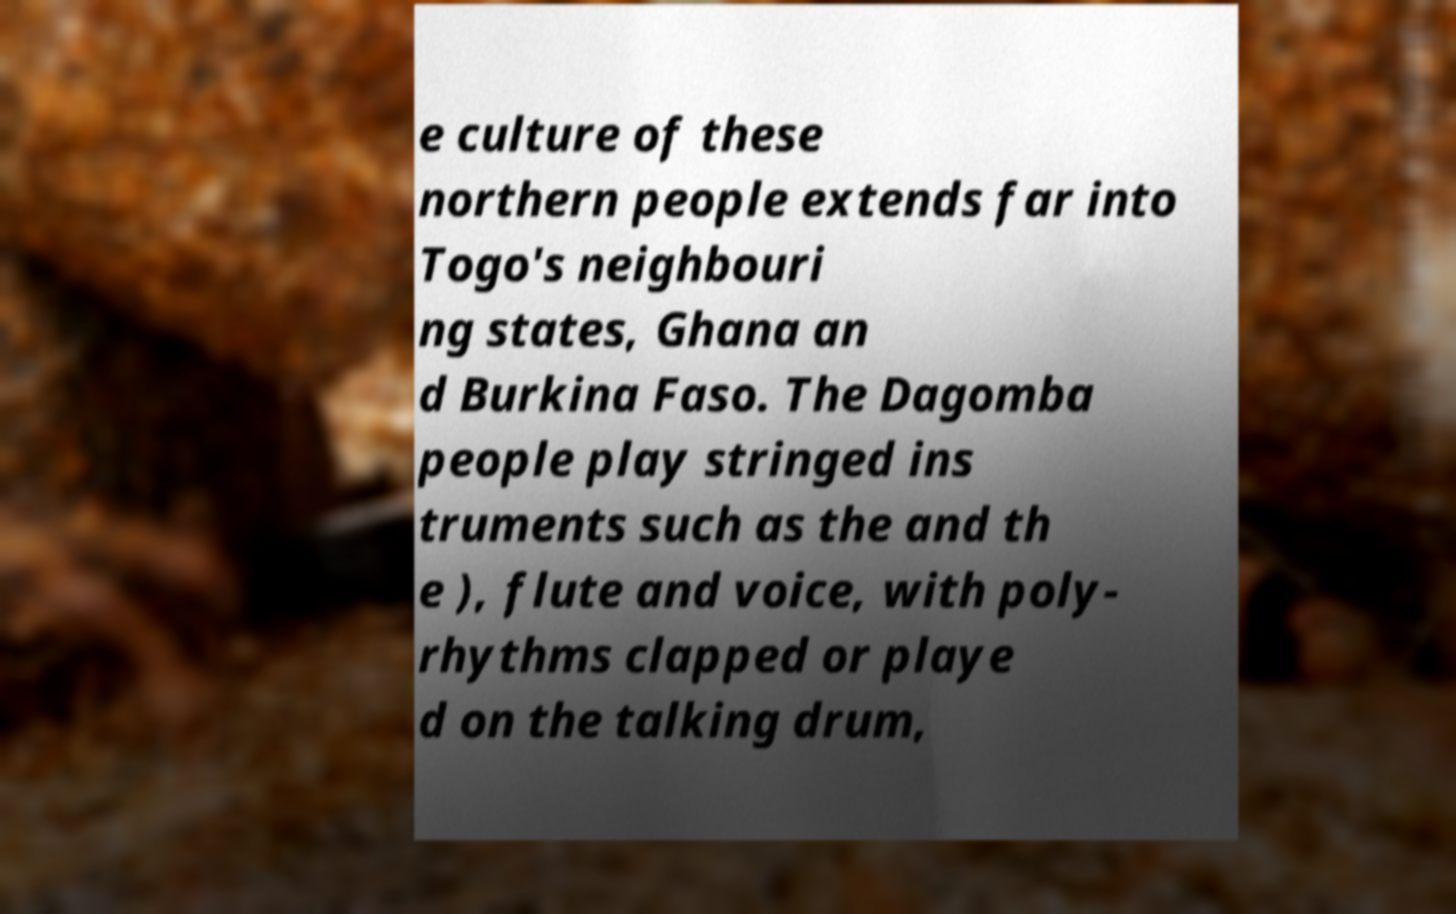Can you accurately transcribe the text from the provided image for me? e culture of these northern people extends far into Togo's neighbouri ng states, Ghana an d Burkina Faso. The Dagomba people play stringed ins truments such as the and th e ), flute and voice, with poly- rhythms clapped or playe d on the talking drum, 